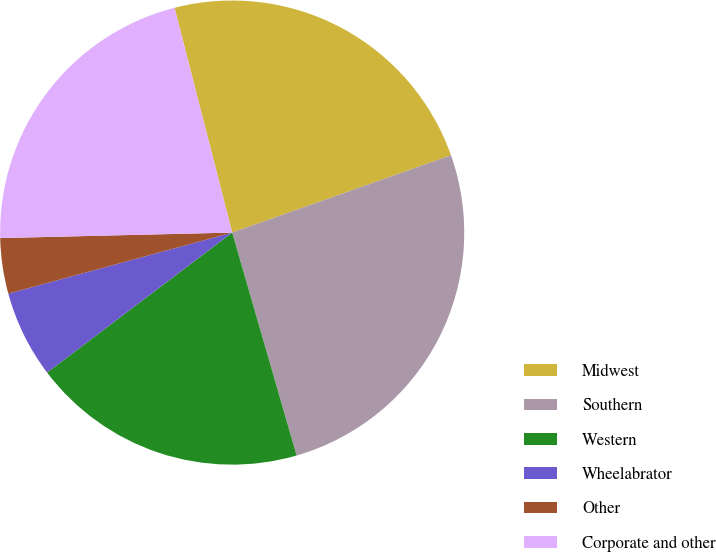Convert chart to OTSL. <chart><loc_0><loc_0><loc_500><loc_500><pie_chart><fcel>Midwest<fcel>Southern<fcel>Western<fcel>Wheelabrator<fcel>Other<fcel>Corporate and other<nl><fcel>23.59%<fcel>25.93%<fcel>19.17%<fcel>6.07%<fcel>3.86%<fcel>21.38%<nl></chart> 